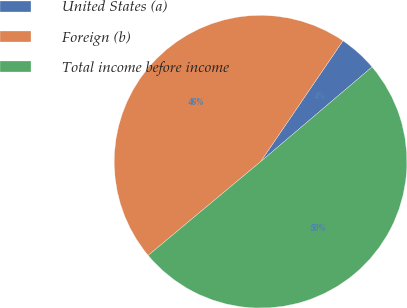Convert chart. <chart><loc_0><loc_0><loc_500><loc_500><pie_chart><fcel>United States (a)<fcel>Foreign (b)<fcel>Total income before income<nl><fcel>4.27%<fcel>45.58%<fcel>50.14%<nl></chart> 